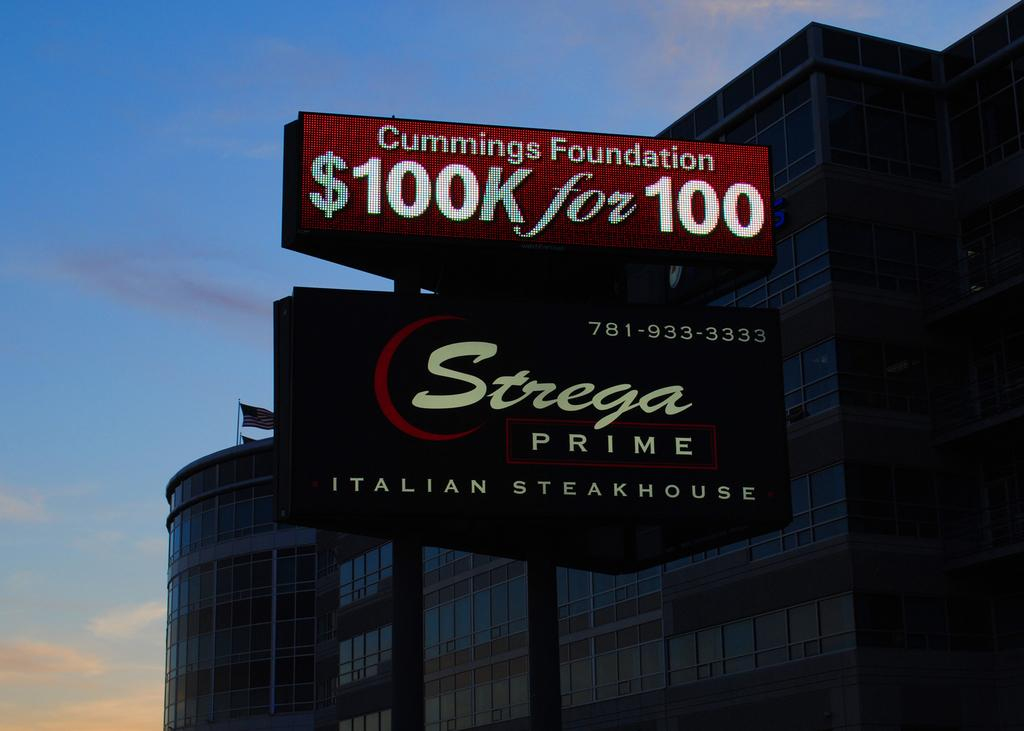<image>
Summarize the visual content of the image. A sign for compensation claims sits above another sign for a steakhouse in front of a large building at dusk. 